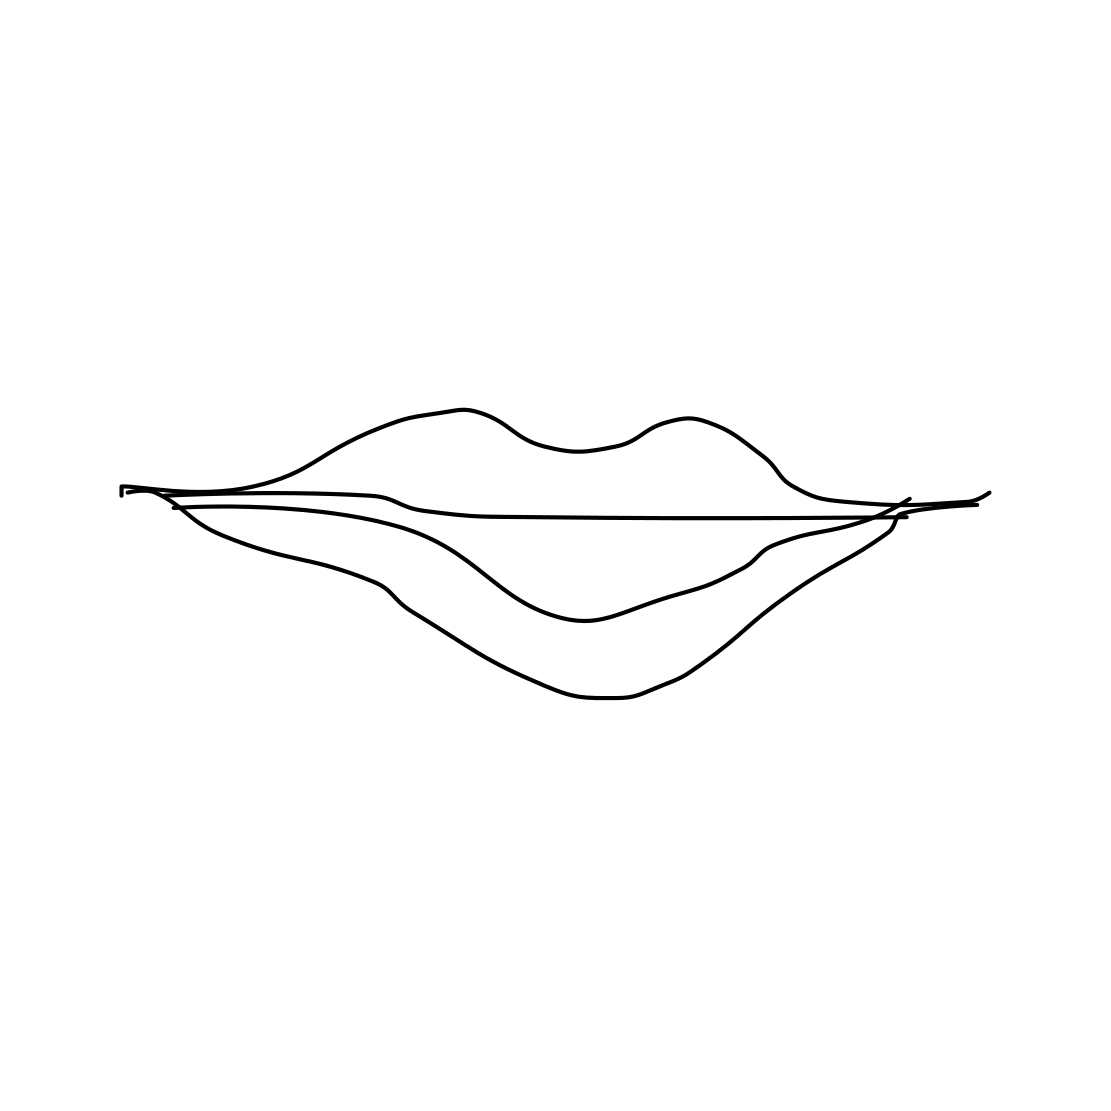What emotions or ideas might this image evoke? The minimalist sketch of lips may evoke ideas of communication, sensuality, or simplicity. It's open to interpretation and could resonate differently with individual viewers. How might the context change if the image had more elements added to it? Adding more elements could shift the focus or theme of the image. For instance, pairing the lips with a speech bubble might suggest dialogue, while additional decorative elements could steer it towards a more romantic or aesthetic motif geared towards art display or merchandise design. 